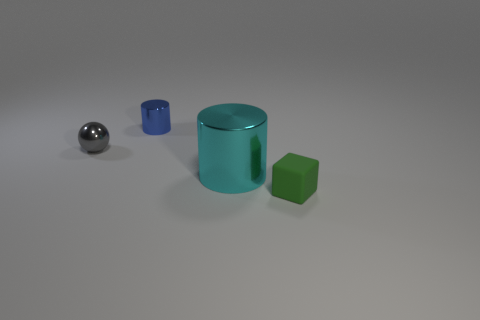Is the material of the green object the same as the small cylinder?
Provide a succinct answer. No. There is a ball that is the same size as the matte object; what is its color?
Keep it short and to the point. Gray. What number of things are either tiny objects behind the cyan thing or objects behind the green matte cube?
Make the answer very short. 3. Do the thing on the left side of the tiny blue thing and the cylinder that is in front of the tiny metal cylinder have the same material?
Your response must be concise. Yes. The tiny object in front of the metal object to the right of the blue cylinder is what shape?
Your answer should be compact. Cube. Is there any other thing that is the same color as the small cylinder?
Your response must be concise. No. There is a small gray sphere left of the metallic cylinder that is on the right side of the blue cylinder; are there any metallic things in front of it?
Your answer should be compact. Yes. Is the color of the metal cylinder on the right side of the tiny cylinder the same as the object to the right of the cyan cylinder?
Offer a terse response. No. What is the material of the ball that is the same size as the green rubber object?
Provide a succinct answer. Metal. There is a object behind the small metallic object left of the metallic cylinder behind the tiny ball; what size is it?
Provide a succinct answer. Small. 